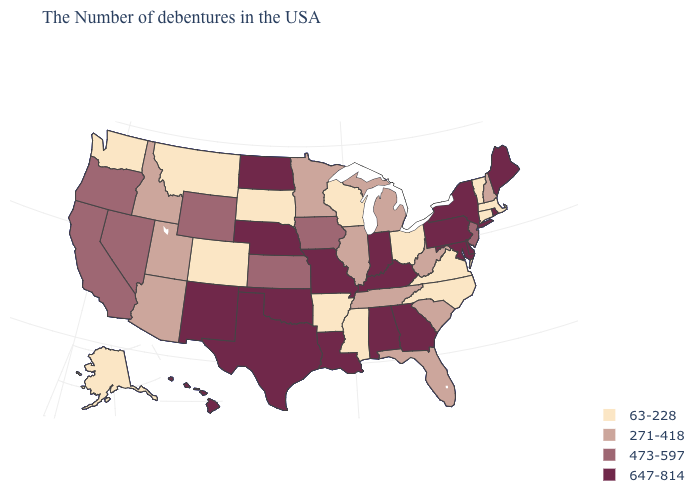Which states have the highest value in the USA?
Keep it brief. Maine, Rhode Island, New York, Delaware, Maryland, Pennsylvania, Georgia, Kentucky, Indiana, Alabama, Louisiana, Missouri, Nebraska, Oklahoma, Texas, North Dakota, New Mexico, Hawaii. Does Delaware have the same value as Maryland?
Keep it brief. Yes. What is the value of Iowa?
Answer briefly. 473-597. Name the states that have a value in the range 473-597?
Give a very brief answer. New Jersey, Iowa, Kansas, Wyoming, Nevada, California, Oregon. Which states hav the highest value in the West?
Quick response, please. New Mexico, Hawaii. What is the lowest value in states that border Minnesota?
Quick response, please. 63-228. Name the states that have a value in the range 647-814?
Concise answer only. Maine, Rhode Island, New York, Delaware, Maryland, Pennsylvania, Georgia, Kentucky, Indiana, Alabama, Louisiana, Missouri, Nebraska, Oklahoma, Texas, North Dakota, New Mexico, Hawaii. Name the states that have a value in the range 473-597?
Give a very brief answer. New Jersey, Iowa, Kansas, Wyoming, Nevada, California, Oregon. How many symbols are there in the legend?
Answer briefly. 4. Name the states that have a value in the range 647-814?
Keep it brief. Maine, Rhode Island, New York, Delaware, Maryland, Pennsylvania, Georgia, Kentucky, Indiana, Alabama, Louisiana, Missouri, Nebraska, Oklahoma, Texas, North Dakota, New Mexico, Hawaii. What is the highest value in states that border West Virginia?
Keep it brief. 647-814. Which states have the lowest value in the South?
Keep it brief. Virginia, North Carolina, Mississippi, Arkansas. Which states hav the highest value in the West?
Keep it brief. New Mexico, Hawaii. Name the states that have a value in the range 647-814?
Short answer required. Maine, Rhode Island, New York, Delaware, Maryland, Pennsylvania, Georgia, Kentucky, Indiana, Alabama, Louisiana, Missouri, Nebraska, Oklahoma, Texas, North Dakota, New Mexico, Hawaii. How many symbols are there in the legend?
Answer briefly. 4. 